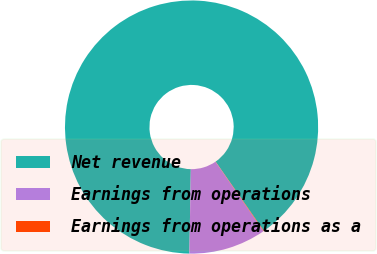Convert chart to OTSL. <chart><loc_0><loc_0><loc_500><loc_500><pie_chart><fcel>Net revenue<fcel>Earnings from operations<fcel>Earnings from operations as a<nl><fcel>90.05%<fcel>9.89%<fcel>0.06%<nl></chart> 